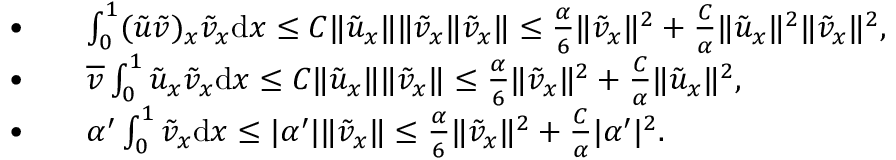Convert formula to latex. <formula><loc_0><loc_0><loc_500><loc_500>\begin{array} { r l } { \bullet \quad } & { \int _ { 0 } ^ { 1 } ( { \tilde { u } } { \tilde { v } } ) _ { x } { \tilde { v } } _ { x } { d x } \leq C \| { \tilde { u } } _ { x } \| \| { \tilde { v } } _ { x } \| { \tilde { v } } _ { x } \| \leq \frac { \alpha } { 6 } \| { \tilde { v } } _ { x } \| ^ { 2 } + \frac { C } { \alpha } \| { \tilde { u } } _ { x } \| ^ { 2 } \| { \tilde { v } } _ { x } \| ^ { 2 } , } \\ { \bullet \quad } & { \overline { v } \int _ { 0 } ^ { 1 } { \tilde { u } } _ { x } { \tilde { v } } _ { x } { d x } \leq C \| { \tilde { u } } _ { x } \| \| { \tilde { v } } _ { x } \| \leq \frac { \alpha } { 6 } \| { \tilde { v } } _ { x } \| ^ { 2 } + \frac { C } { \alpha } \| { \tilde { u } } _ { x } \| ^ { 2 } , } \\ { \bullet \quad } & { \alpha ^ { \prime } \int _ { 0 } ^ { 1 } { \tilde { v } } _ { x } { d x } \leq | \alpha ^ { \prime } | \| { \tilde { v } } _ { x } \| \leq \frac { \alpha } { 6 } \| { \tilde { v } } _ { x } \| ^ { 2 } + \frac { C } { \alpha } | \alpha ^ { \prime } | ^ { 2 } . } \end{array}</formula> 